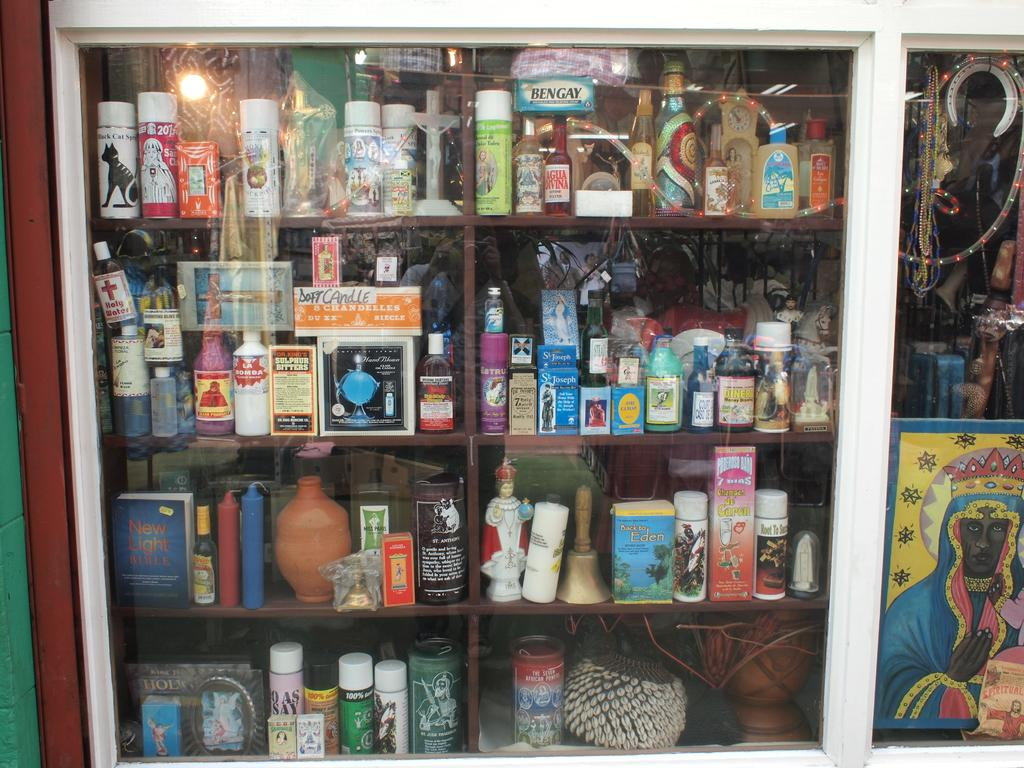<image>
Describe the image concisely. Shelf with a door that has an object called Sulphur Bitters inside. 